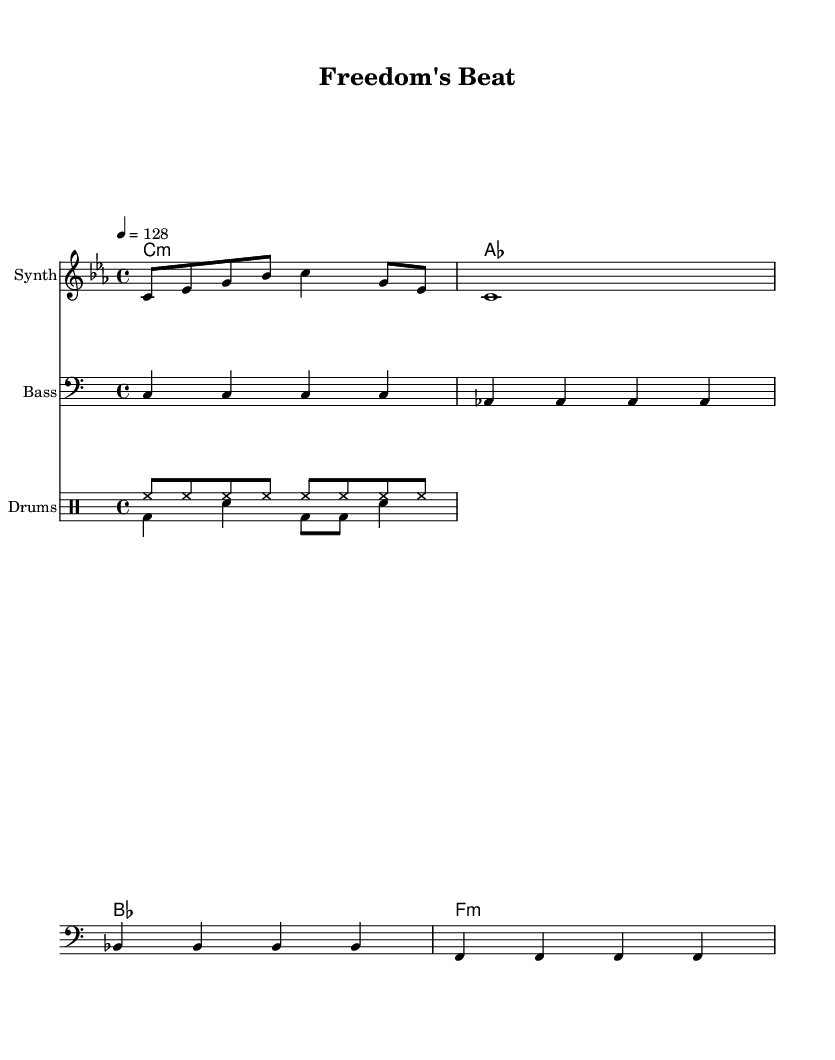What is the key signature of this music? The key signature shows that the piece is in C minor, which has three flats (B flat, E flat, and A flat). This is clearly indicated at the beginning of the staff.
Answer: C minor What is the time signature of this music? The time signature is indicated by the numbers at the beginning of the score, showing that there are four beats in a measure and the quarter note receives one beat.
Answer: 4/4 What is the tempo marking for this piece? The tempo is provided near the beginning of the score, indicating a speed of 128 beats per minute, setting an upbeat pace suitable for dance music.
Answer: 128 How many measures are in the melody section? By counting the individual measures in the melody, there are four distinct measures before the melody concludes, as each measure is separated by a vertical line (bar line).
Answer: 4 What instrument is labeled as playing the melody? The instrument that plays the melody is designated as "Synth" at the beginning of the respective staff section, indicating that synthesizers typically create the melodic lines in electronic music.
Answer: Synth What is the rhythm of the drum pattern labeled as "Down"? The drum pattern labeled "Down" is indicated with specific note symbols that suggest a rhythmic sequence involving a bass drum and snare; the bass drum and snare combination creates a distinct backbeat.
Answer: bass drum and snare Which chord follows the chord of A-flat in the harmony? Following the A-flat chord in the provided harmony section comes the B-flat chord, as indicated by the order of the chord symbols. This logical progression is typical in music theory.
Answer: B-flat 